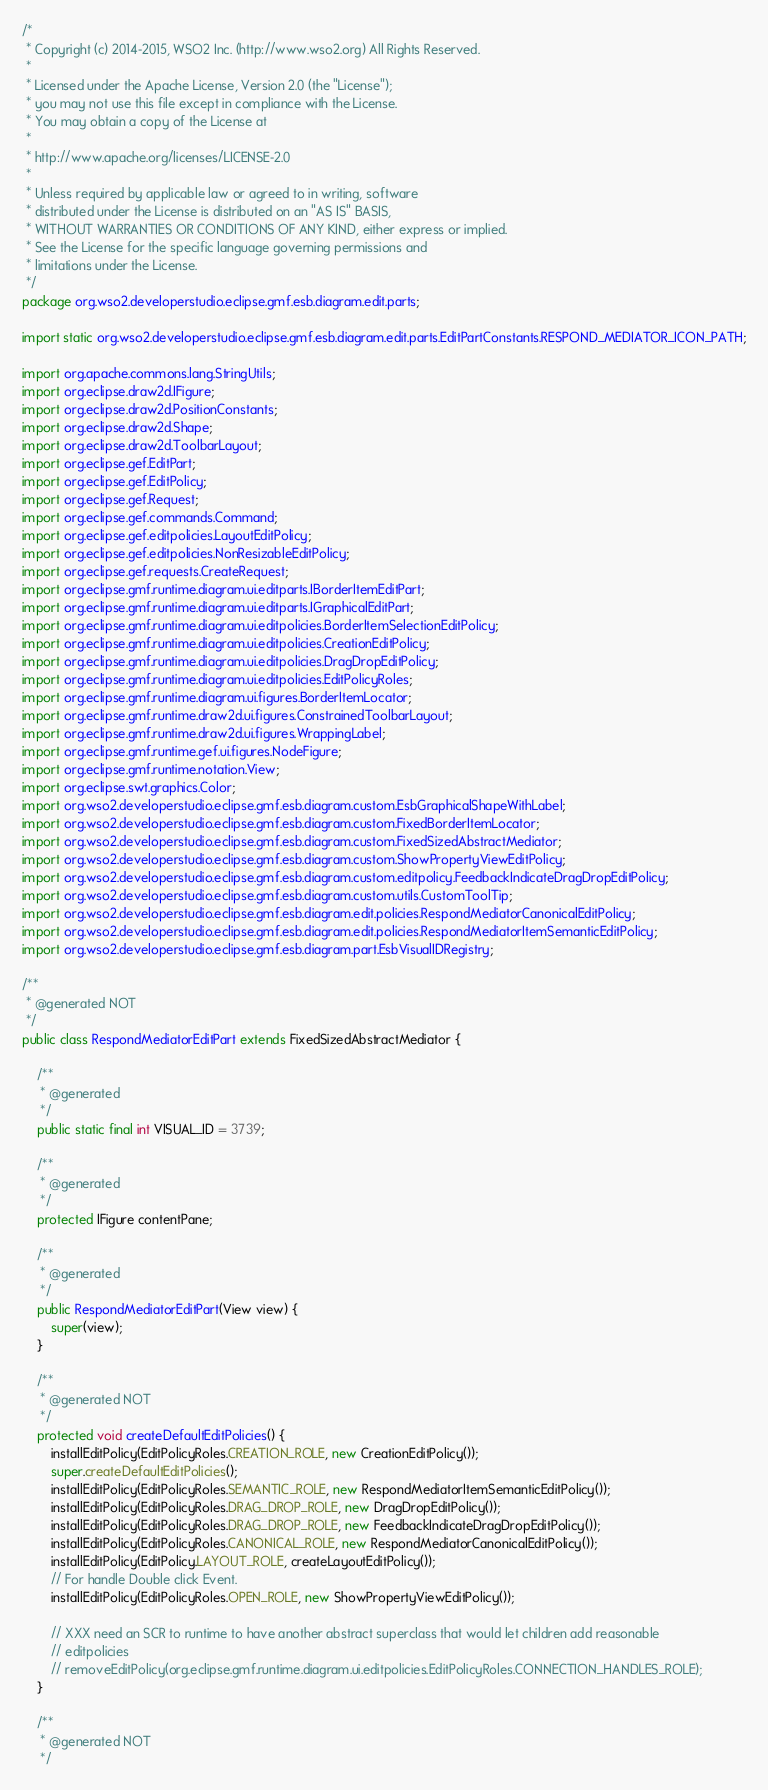Convert code to text. <code><loc_0><loc_0><loc_500><loc_500><_Java_>/*
 * Copyright (c) 2014-2015, WSO2 Inc. (http://www.wso2.org) All Rights Reserved.
 * 
 * Licensed under the Apache License, Version 2.0 (the "License");
 * you may not use this file except in compliance with the License.
 * You may obtain a copy of the License at
 * 
 * http://www.apache.org/licenses/LICENSE-2.0
 * 
 * Unless required by applicable law or agreed to in writing, software
 * distributed under the License is distributed on an "AS IS" BASIS,
 * WITHOUT WARRANTIES OR CONDITIONS OF ANY KIND, either express or implied.
 * See the License for the specific language governing permissions and
 * limitations under the License.
 */
package org.wso2.developerstudio.eclipse.gmf.esb.diagram.edit.parts;

import static org.wso2.developerstudio.eclipse.gmf.esb.diagram.edit.parts.EditPartConstants.RESPOND_MEDIATOR_ICON_PATH;

import org.apache.commons.lang.StringUtils;
import org.eclipse.draw2d.IFigure;
import org.eclipse.draw2d.PositionConstants;
import org.eclipse.draw2d.Shape;
import org.eclipse.draw2d.ToolbarLayout;
import org.eclipse.gef.EditPart;
import org.eclipse.gef.EditPolicy;
import org.eclipse.gef.Request;
import org.eclipse.gef.commands.Command;
import org.eclipse.gef.editpolicies.LayoutEditPolicy;
import org.eclipse.gef.editpolicies.NonResizableEditPolicy;
import org.eclipse.gef.requests.CreateRequest;
import org.eclipse.gmf.runtime.diagram.ui.editparts.IBorderItemEditPart;
import org.eclipse.gmf.runtime.diagram.ui.editparts.IGraphicalEditPart;
import org.eclipse.gmf.runtime.diagram.ui.editpolicies.BorderItemSelectionEditPolicy;
import org.eclipse.gmf.runtime.diagram.ui.editpolicies.CreationEditPolicy;
import org.eclipse.gmf.runtime.diagram.ui.editpolicies.DragDropEditPolicy;
import org.eclipse.gmf.runtime.diagram.ui.editpolicies.EditPolicyRoles;
import org.eclipse.gmf.runtime.diagram.ui.figures.BorderItemLocator;
import org.eclipse.gmf.runtime.draw2d.ui.figures.ConstrainedToolbarLayout;
import org.eclipse.gmf.runtime.draw2d.ui.figures.WrappingLabel;
import org.eclipse.gmf.runtime.gef.ui.figures.NodeFigure;
import org.eclipse.gmf.runtime.notation.View;
import org.eclipse.swt.graphics.Color;
import org.wso2.developerstudio.eclipse.gmf.esb.diagram.custom.EsbGraphicalShapeWithLabel;
import org.wso2.developerstudio.eclipse.gmf.esb.diagram.custom.FixedBorderItemLocator;
import org.wso2.developerstudio.eclipse.gmf.esb.diagram.custom.FixedSizedAbstractMediator;
import org.wso2.developerstudio.eclipse.gmf.esb.diagram.custom.ShowPropertyViewEditPolicy;
import org.wso2.developerstudio.eclipse.gmf.esb.diagram.custom.editpolicy.FeedbackIndicateDragDropEditPolicy;
import org.wso2.developerstudio.eclipse.gmf.esb.diagram.custom.utils.CustomToolTip;
import org.wso2.developerstudio.eclipse.gmf.esb.diagram.edit.policies.RespondMediatorCanonicalEditPolicy;
import org.wso2.developerstudio.eclipse.gmf.esb.diagram.edit.policies.RespondMediatorItemSemanticEditPolicy;
import org.wso2.developerstudio.eclipse.gmf.esb.diagram.part.EsbVisualIDRegistry;

/**
 * @generated NOT
 */
public class RespondMediatorEditPart extends FixedSizedAbstractMediator {

    /**
     * @generated
     */
    public static final int VISUAL_ID = 3739;

    /**
     * @generated
     */
    protected IFigure contentPane;

    /**
     * @generated
     */
    public RespondMediatorEditPart(View view) {
        super(view);
    }

    /**
     * @generated NOT
     */
    protected void createDefaultEditPolicies() {
        installEditPolicy(EditPolicyRoles.CREATION_ROLE, new CreationEditPolicy());
        super.createDefaultEditPolicies();
        installEditPolicy(EditPolicyRoles.SEMANTIC_ROLE, new RespondMediatorItemSemanticEditPolicy());
        installEditPolicy(EditPolicyRoles.DRAG_DROP_ROLE, new DragDropEditPolicy());
        installEditPolicy(EditPolicyRoles.DRAG_DROP_ROLE, new FeedbackIndicateDragDropEditPolicy());
        installEditPolicy(EditPolicyRoles.CANONICAL_ROLE, new RespondMediatorCanonicalEditPolicy());
        installEditPolicy(EditPolicy.LAYOUT_ROLE, createLayoutEditPolicy());
        // For handle Double click Event.
        installEditPolicy(EditPolicyRoles.OPEN_ROLE, new ShowPropertyViewEditPolicy());

        // XXX need an SCR to runtime to have another abstract superclass that would let children add reasonable
        // editpolicies
        // removeEditPolicy(org.eclipse.gmf.runtime.diagram.ui.editpolicies.EditPolicyRoles.CONNECTION_HANDLES_ROLE);
    }

    /**
     * @generated NOT
     */</code> 